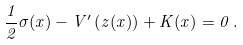Convert formula to latex. <formula><loc_0><loc_0><loc_500><loc_500>\frac { 1 } { 2 } \sigma ( x ) - V ^ { \prime } \left ( z ( x ) \right ) + K ( x ) = 0 \, .</formula> 